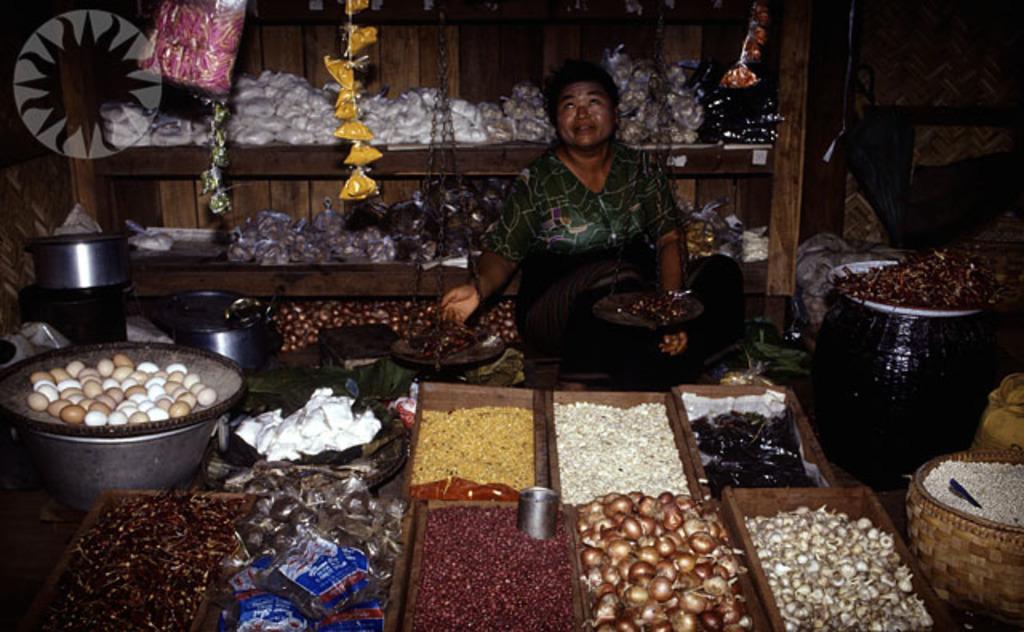Could you give a brief overview of what you see in this image? In the picture I can see a person is sitting. I can also see vegetables, onions and some other objects. In the background I can see wooden shelf which has some objects on it. 